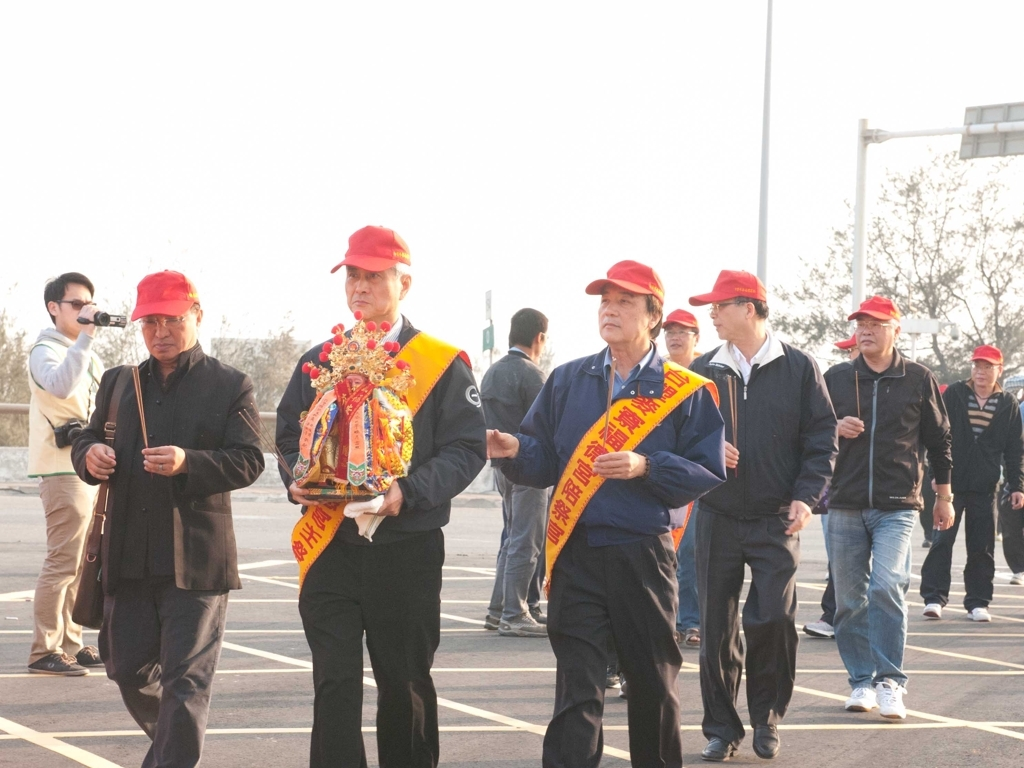Can you comment on the symbolism of the items being carried in the procession? The central item carried by the man in the forefront appears to be a decorated ritual object, likely serving as a focal point of the event. It may represent a deity or symbolize blessings and good fortune, depending on the specific cultural context. Such items are typically revered and are believed to carry significant spiritual weight during such processions. Could you infer any cultural or regional specifics based on the clothing and the items? Although we should be cautious about making definitive cultural assumptions without specific context, the attire and the items bear resemblance to traditional East Asian ceremonial practices, particularly those found in Chinese culture. Red is often a color denoting good luck and joy in many Asian cultures, and the use of golden characters would traditionally signify prosperity and reverence. 